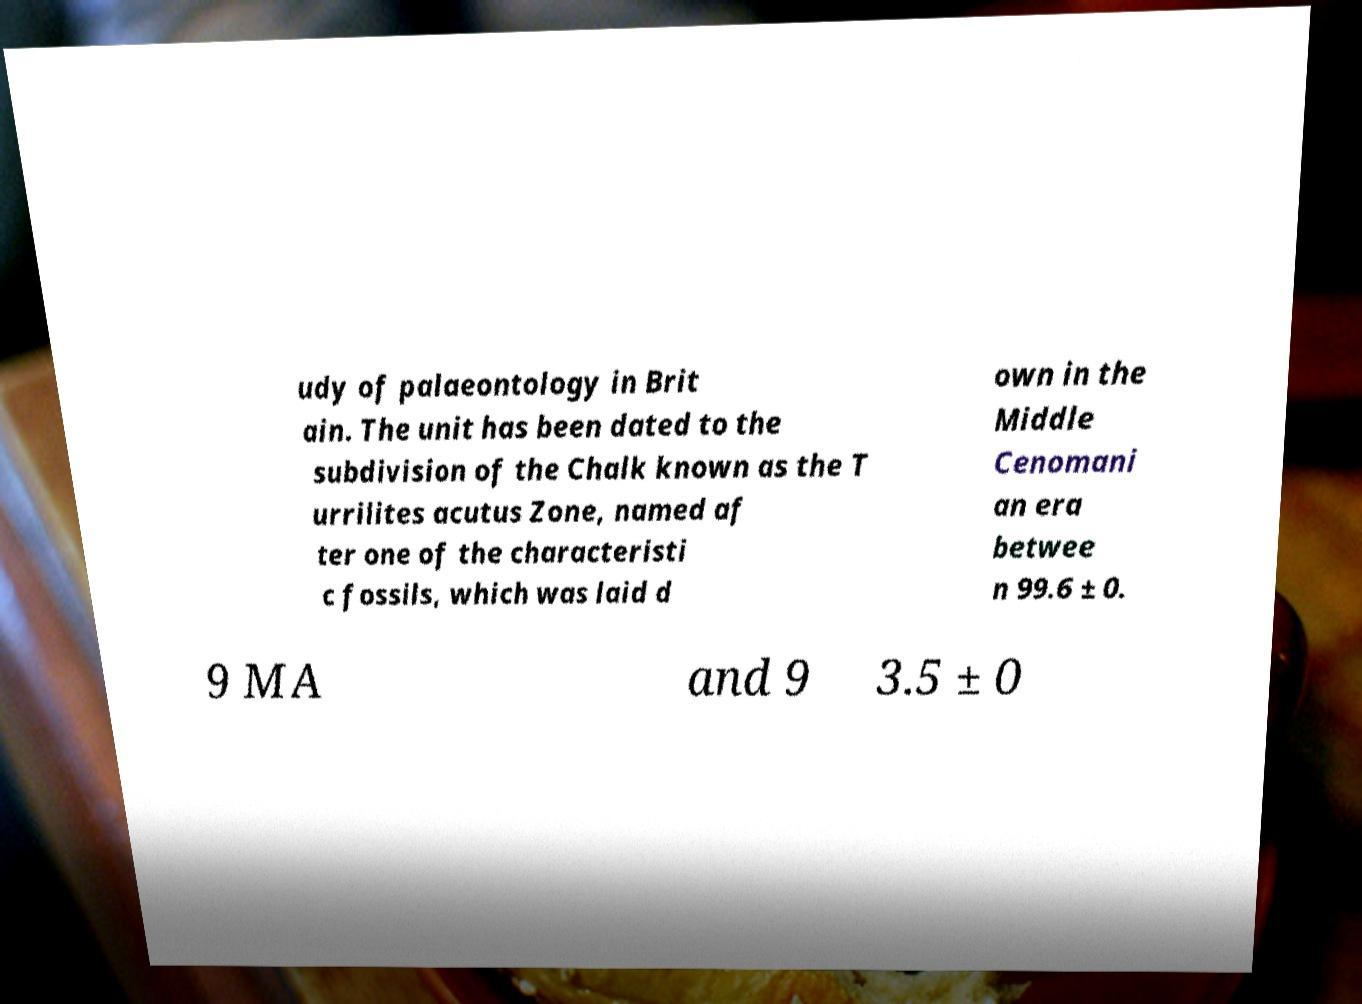Please read and relay the text visible in this image. What does it say? udy of palaeontology in Brit ain. The unit has been dated to the subdivision of the Chalk known as the T urrilites acutus Zone, named af ter one of the characteristi c fossils, which was laid d own in the Middle Cenomani an era betwee n 99.6 ± 0. 9 MA and 9 3.5 ± 0 